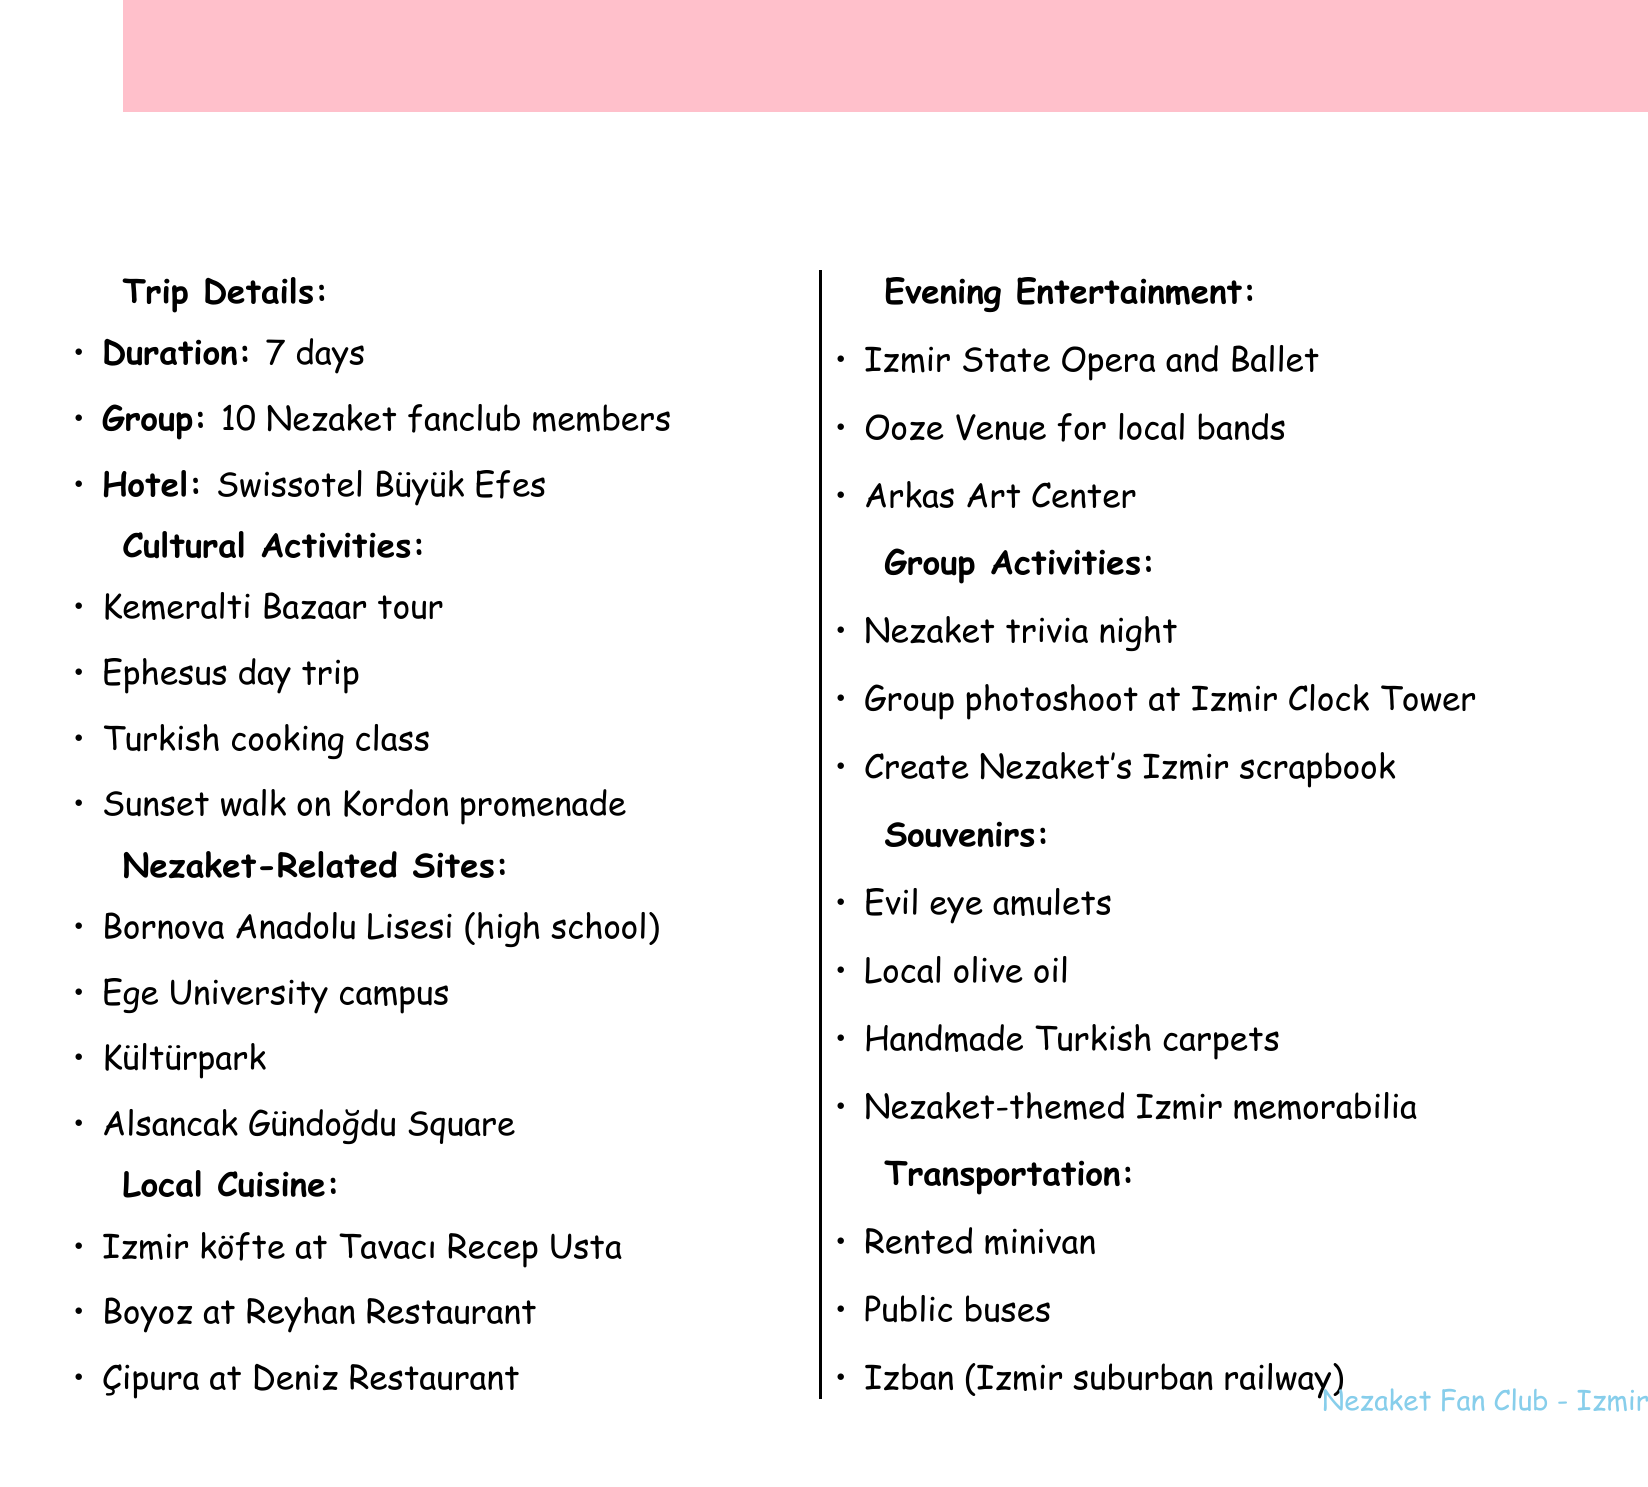What is the purpose of the trip? The trip's purpose is to immerse in cultural experiences and focus on Nezaket's tours in her hometown.
Answer: Cultural immersion and Nezaket-focused tour in Izmir, Turkey What is the duration of the trip? The document specifies the trip's duration in days, which is highlighted.
Answer: 7 days How many members are in the group? The number of members in the trip group is provided, which indicates the size of the fanclub participating.
Answer: 10 Nezaket fanclub members What hotel will the group stay at? The accommodation details include the name of the hotel where the group will reside.
Answer: Swissotel Büyük Efes What cultural activity involves shopping? The cultural activity that mentions shopping at a historic market is clearly indicated in the document.
Answer: Visit to Kemeralti Bazaar Which site is Nezaket's alma mater? The document lists educational institutions, and one is explicitly stated as Nezaket's alma mater.
Answer: Ege University What is Nezaket's go-to comfort food? The document lists local cuisine and identifies a specific dish as Nezaket's favorite comfort food.
Answer: Izmir köfte Which venue is mentioned for attending performances? The evening entertainment section lists venues, and one is specified for performances, especially if Nezaket is starring.
Answer: Izmir State Opera and Ballet What group activity involves trivia? The group activities section includes an activity focused on Nezaket trivia, which signifies an interactive experience among fans.
Answer: Nezaket trivia night at the hotel 